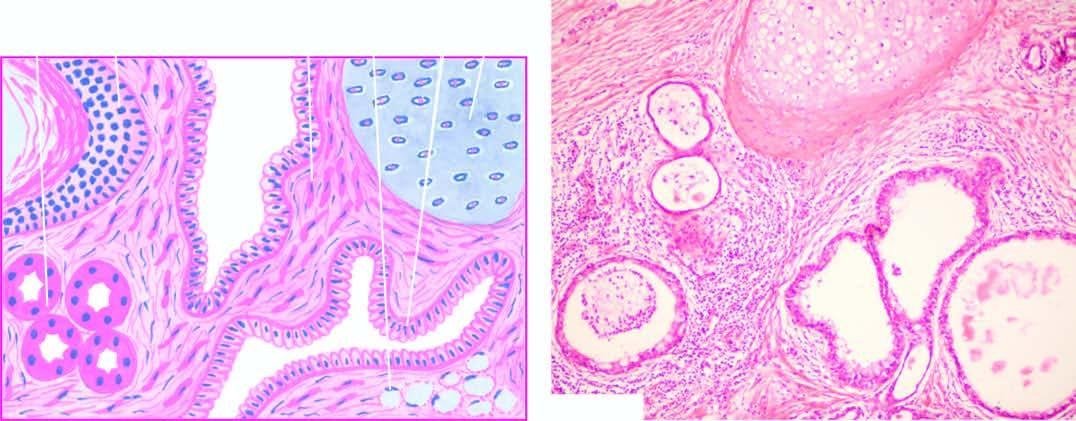does mall show characteristic lining of the cyst wall by epidermis and its appendages?
Answer the question using a single word or phrase. No 